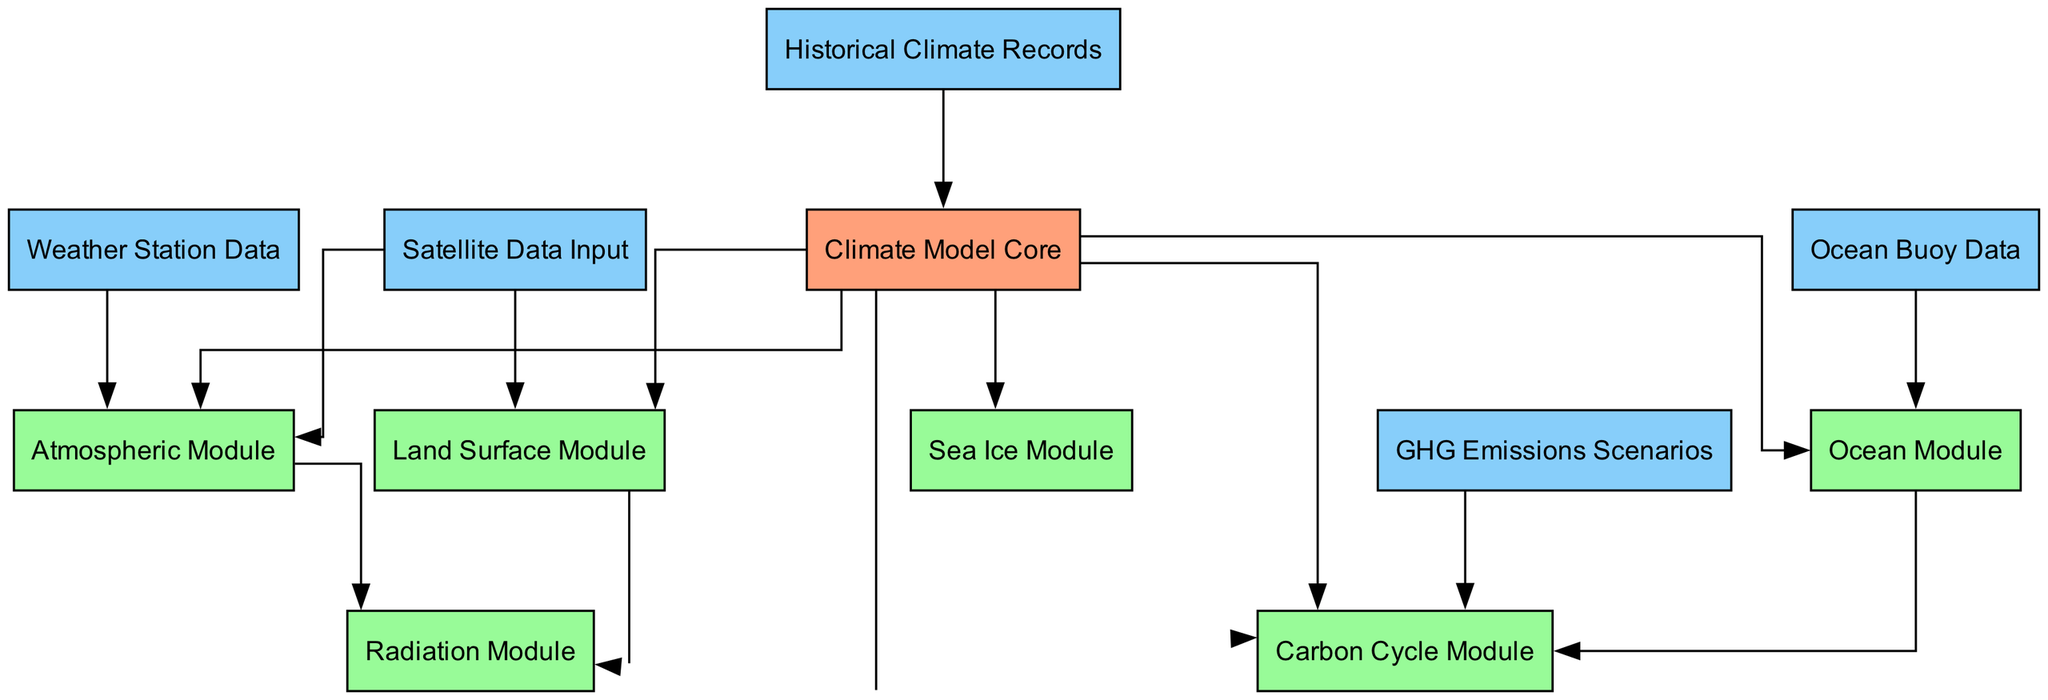What is the total number of nodes in the diagram? By counting each unique entry in the nodes section of the provided data, we find there are 12 distinct nodes: Climate Model Core, Atmospheric Module, Ocean Module, Land Surface Module, Sea Ice Module, Radiation Module, Carbon Cycle Module, Satellite Data Input, Weather Station Data, Ocean Buoy Data, Historical Climate Records, and GHG Emissions Scenarios.
Answer: 12 Which module is dependent on Sea Ice Module? By examining the edges, it's clear that the Sea Ice Module only connects to the Climate Model Core, and it does not direct to any other module, indicating there is no module dependent on Sea Ice Module.
Answer: None What type of data input is connected to the Atmospheric Module? Looking through the edges, both Satellite Data Input and Weather Station Data point to the Atmospheric Module, confirming that it receives inputs from these two data sources.
Answer: Satellite Data Input, Weather Station Data How many modules connect to the Climate Model Core? The edges show that the Climate Model Core connects to six modules: Atmospheric Module, Ocean Module, Land Surface Module, Sea Ice Module, Radiation Module, and Carbon Cycle Module. Thus, we find that there are six module dependencies.
Answer: 6 Which module processes GHG Emissions Scenarios data? The edge connecting GHG Emissions Scenarios specifically leads to the Carbon Cycle Module, meaning that this module is the one that processes the emissions scenarios data.
Answer: Carbon Cycle Module What is the relationship between the Ocean Module and the Carbon Cycle Module? The edges indicate a directed connection from the Ocean Module to the Carbon Cycle Module, meaning that the Ocean Module provides data input that is utilized by the Carbon Cycle Module. This signifies a dependency relationship where the Carbon Cycle Module relies on outputs from the Ocean Module.
Answer: Ocean Module to Carbon Cycle Module Which data source connects to multiple modules in the diagram? Upon scrutiny, both Satellite Data Input and Weather Station Data connect to the Atmospheric Module and the Land Surface Module, making them the data sources that serve multiple modules in this climate model structure.
Answer: Satellite Data Input, Weather Station Data What is the primary source of historical data in the model? The edge from Historical Climate Records connects directly to the Climate Model Core, highlighting this as the primary source for historical data that informs the overall climate model.
Answer: Historical Climate Records How many modules receive direct inputs from data sources? By checking the edges, we see that the Atmospheric Module, Ocean Module, and Land Surface Module receive direct inputs from data sources (specifically from Satellite Data Input, Ocean Buoy Data, and Weather Station Data). These three modules can be classified as ones that receive direct data inputs, leading to a count of three.
Answer: 3 